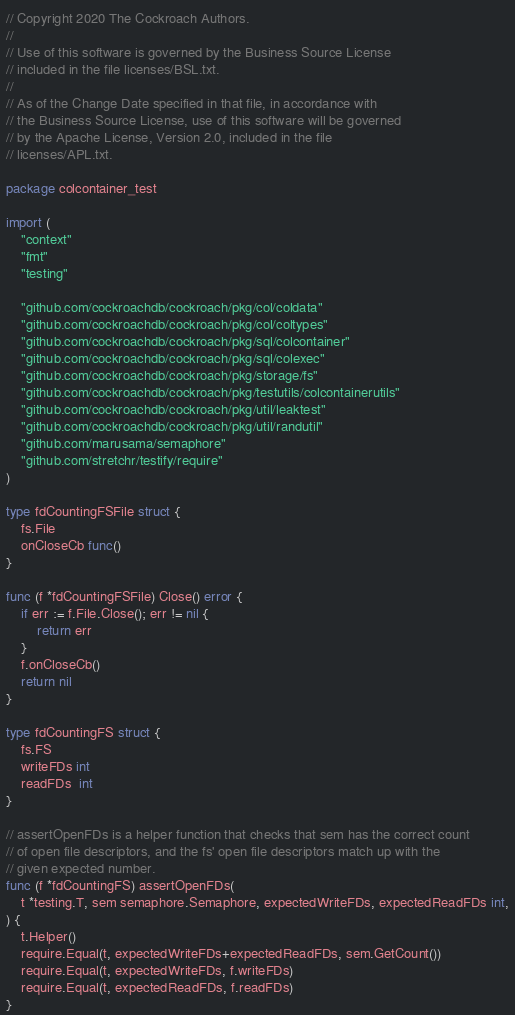<code> <loc_0><loc_0><loc_500><loc_500><_Go_>// Copyright 2020 The Cockroach Authors.
//
// Use of this software is governed by the Business Source License
// included in the file licenses/BSL.txt.
//
// As of the Change Date specified in that file, in accordance with
// the Business Source License, use of this software will be governed
// by the Apache License, Version 2.0, included in the file
// licenses/APL.txt.

package colcontainer_test

import (
	"context"
	"fmt"
	"testing"

	"github.com/cockroachdb/cockroach/pkg/col/coldata"
	"github.com/cockroachdb/cockroach/pkg/col/coltypes"
	"github.com/cockroachdb/cockroach/pkg/sql/colcontainer"
	"github.com/cockroachdb/cockroach/pkg/sql/colexec"
	"github.com/cockroachdb/cockroach/pkg/storage/fs"
	"github.com/cockroachdb/cockroach/pkg/testutils/colcontainerutils"
	"github.com/cockroachdb/cockroach/pkg/util/leaktest"
	"github.com/cockroachdb/cockroach/pkg/util/randutil"
	"github.com/marusama/semaphore"
	"github.com/stretchr/testify/require"
)

type fdCountingFSFile struct {
	fs.File
	onCloseCb func()
}

func (f *fdCountingFSFile) Close() error {
	if err := f.File.Close(); err != nil {
		return err
	}
	f.onCloseCb()
	return nil
}

type fdCountingFS struct {
	fs.FS
	writeFDs int
	readFDs  int
}

// assertOpenFDs is a helper function that checks that sem has the correct count
// of open file descriptors, and the fs' open file descriptors match up with the
// given expected number.
func (f *fdCountingFS) assertOpenFDs(
	t *testing.T, sem semaphore.Semaphore, expectedWriteFDs, expectedReadFDs int,
) {
	t.Helper()
	require.Equal(t, expectedWriteFDs+expectedReadFDs, sem.GetCount())
	require.Equal(t, expectedWriteFDs, f.writeFDs)
	require.Equal(t, expectedReadFDs, f.readFDs)
}
</code> 